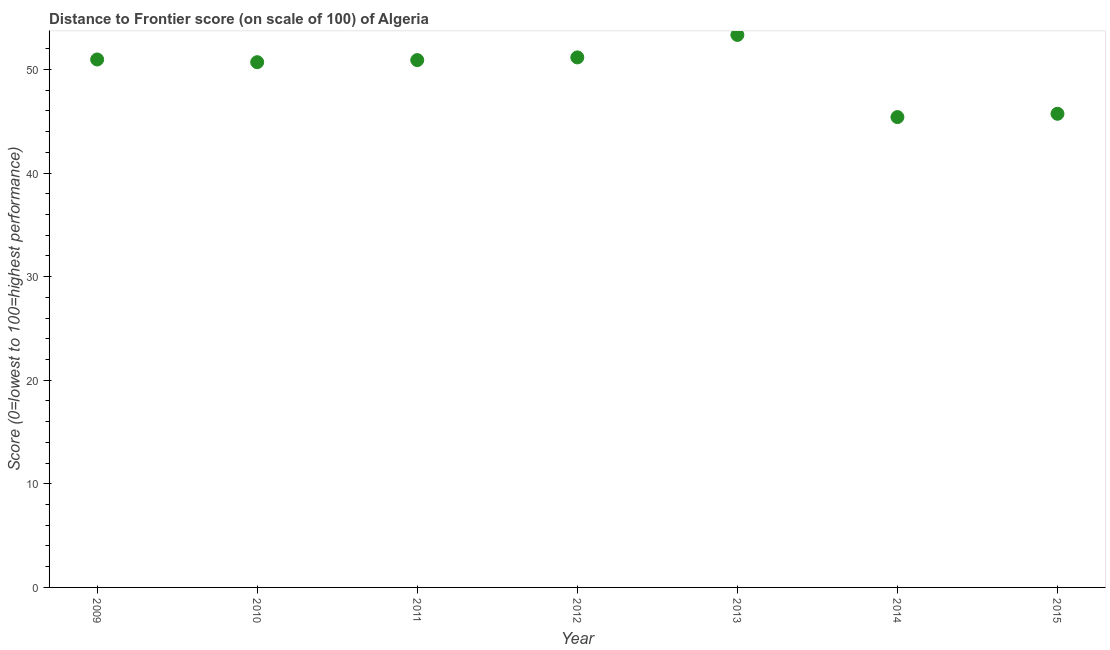What is the distance to frontier score in 2009?
Provide a short and direct response. 50.96. Across all years, what is the maximum distance to frontier score?
Your response must be concise. 53.33. Across all years, what is the minimum distance to frontier score?
Your response must be concise. 45.4. What is the sum of the distance to frontier score?
Ensure brevity in your answer.  348.17. What is the difference between the distance to frontier score in 2010 and 2015?
Provide a succinct answer. 4.98. What is the average distance to frontier score per year?
Your response must be concise. 49.74. What is the median distance to frontier score?
Offer a very short reply. 50.9. In how many years, is the distance to frontier score greater than 22 ?
Give a very brief answer. 7. Do a majority of the years between 2015 and 2014 (inclusive) have distance to frontier score greater than 8 ?
Make the answer very short. No. What is the ratio of the distance to frontier score in 2013 to that in 2015?
Your response must be concise. 1.17. Is the distance to frontier score in 2009 less than that in 2014?
Make the answer very short. No. What is the difference between the highest and the second highest distance to frontier score?
Ensure brevity in your answer.  2.17. What is the difference between the highest and the lowest distance to frontier score?
Offer a very short reply. 7.93. In how many years, is the distance to frontier score greater than the average distance to frontier score taken over all years?
Provide a short and direct response. 5. Does the distance to frontier score monotonically increase over the years?
Your response must be concise. No. How many dotlines are there?
Offer a terse response. 1. Are the values on the major ticks of Y-axis written in scientific E-notation?
Ensure brevity in your answer.  No. Does the graph contain any zero values?
Keep it short and to the point. No. What is the title of the graph?
Your answer should be compact. Distance to Frontier score (on scale of 100) of Algeria. What is the label or title of the X-axis?
Keep it short and to the point. Year. What is the label or title of the Y-axis?
Your response must be concise. Score (0=lowest to 100=highest performance). What is the Score (0=lowest to 100=highest performance) in 2009?
Give a very brief answer. 50.96. What is the Score (0=lowest to 100=highest performance) in 2010?
Provide a succinct answer. 50.7. What is the Score (0=lowest to 100=highest performance) in 2011?
Provide a short and direct response. 50.9. What is the Score (0=lowest to 100=highest performance) in 2012?
Offer a terse response. 51.16. What is the Score (0=lowest to 100=highest performance) in 2013?
Ensure brevity in your answer.  53.33. What is the Score (0=lowest to 100=highest performance) in 2014?
Ensure brevity in your answer.  45.4. What is the Score (0=lowest to 100=highest performance) in 2015?
Your answer should be compact. 45.72. What is the difference between the Score (0=lowest to 100=highest performance) in 2009 and 2010?
Your answer should be compact. 0.26. What is the difference between the Score (0=lowest to 100=highest performance) in 2009 and 2013?
Keep it short and to the point. -2.37. What is the difference between the Score (0=lowest to 100=highest performance) in 2009 and 2014?
Offer a very short reply. 5.56. What is the difference between the Score (0=lowest to 100=highest performance) in 2009 and 2015?
Provide a short and direct response. 5.24. What is the difference between the Score (0=lowest to 100=highest performance) in 2010 and 2012?
Offer a terse response. -0.46. What is the difference between the Score (0=lowest to 100=highest performance) in 2010 and 2013?
Your response must be concise. -2.63. What is the difference between the Score (0=lowest to 100=highest performance) in 2010 and 2014?
Your answer should be very brief. 5.3. What is the difference between the Score (0=lowest to 100=highest performance) in 2010 and 2015?
Offer a terse response. 4.98. What is the difference between the Score (0=lowest to 100=highest performance) in 2011 and 2012?
Keep it short and to the point. -0.26. What is the difference between the Score (0=lowest to 100=highest performance) in 2011 and 2013?
Provide a short and direct response. -2.43. What is the difference between the Score (0=lowest to 100=highest performance) in 2011 and 2015?
Keep it short and to the point. 5.18. What is the difference between the Score (0=lowest to 100=highest performance) in 2012 and 2013?
Keep it short and to the point. -2.17. What is the difference between the Score (0=lowest to 100=highest performance) in 2012 and 2014?
Provide a short and direct response. 5.76. What is the difference between the Score (0=lowest to 100=highest performance) in 2012 and 2015?
Keep it short and to the point. 5.44. What is the difference between the Score (0=lowest to 100=highest performance) in 2013 and 2014?
Provide a succinct answer. 7.93. What is the difference between the Score (0=lowest to 100=highest performance) in 2013 and 2015?
Your answer should be very brief. 7.61. What is the difference between the Score (0=lowest to 100=highest performance) in 2014 and 2015?
Ensure brevity in your answer.  -0.32. What is the ratio of the Score (0=lowest to 100=highest performance) in 2009 to that in 2010?
Keep it short and to the point. 1. What is the ratio of the Score (0=lowest to 100=highest performance) in 2009 to that in 2012?
Your answer should be very brief. 1. What is the ratio of the Score (0=lowest to 100=highest performance) in 2009 to that in 2013?
Give a very brief answer. 0.96. What is the ratio of the Score (0=lowest to 100=highest performance) in 2009 to that in 2014?
Your answer should be compact. 1.12. What is the ratio of the Score (0=lowest to 100=highest performance) in 2009 to that in 2015?
Offer a very short reply. 1.11. What is the ratio of the Score (0=lowest to 100=highest performance) in 2010 to that in 2011?
Make the answer very short. 1. What is the ratio of the Score (0=lowest to 100=highest performance) in 2010 to that in 2012?
Offer a very short reply. 0.99. What is the ratio of the Score (0=lowest to 100=highest performance) in 2010 to that in 2013?
Your answer should be compact. 0.95. What is the ratio of the Score (0=lowest to 100=highest performance) in 2010 to that in 2014?
Ensure brevity in your answer.  1.12. What is the ratio of the Score (0=lowest to 100=highest performance) in 2010 to that in 2015?
Offer a very short reply. 1.11. What is the ratio of the Score (0=lowest to 100=highest performance) in 2011 to that in 2012?
Give a very brief answer. 0.99. What is the ratio of the Score (0=lowest to 100=highest performance) in 2011 to that in 2013?
Provide a short and direct response. 0.95. What is the ratio of the Score (0=lowest to 100=highest performance) in 2011 to that in 2014?
Provide a short and direct response. 1.12. What is the ratio of the Score (0=lowest to 100=highest performance) in 2011 to that in 2015?
Provide a short and direct response. 1.11. What is the ratio of the Score (0=lowest to 100=highest performance) in 2012 to that in 2014?
Your answer should be compact. 1.13. What is the ratio of the Score (0=lowest to 100=highest performance) in 2012 to that in 2015?
Offer a very short reply. 1.12. What is the ratio of the Score (0=lowest to 100=highest performance) in 2013 to that in 2014?
Ensure brevity in your answer.  1.18. What is the ratio of the Score (0=lowest to 100=highest performance) in 2013 to that in 2015?
Your response must be concise. 1.17. 